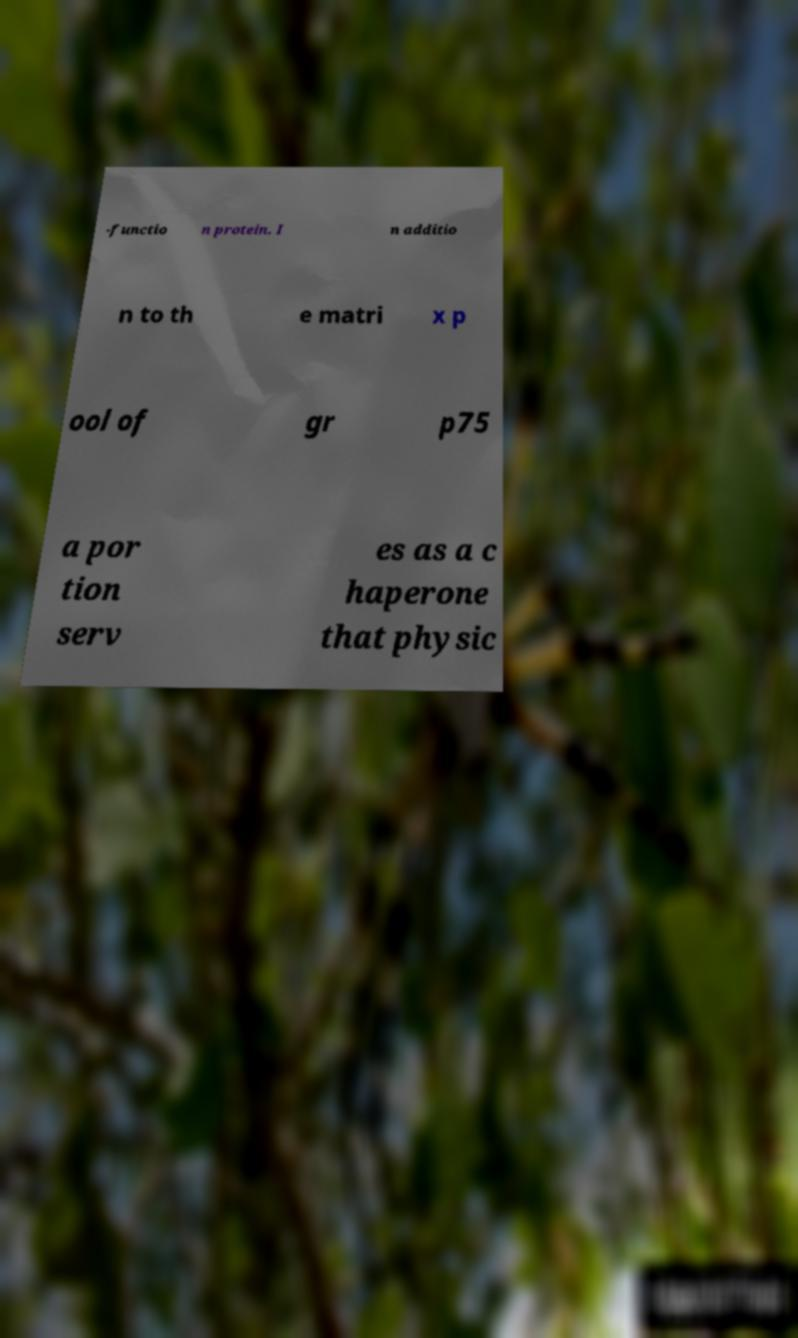Please read and relay the text visible in this image. What does it say? -functio n protein. I n additio n to th e matri x p ool of gr p75 a por tion serv es as a c haperone that physic 